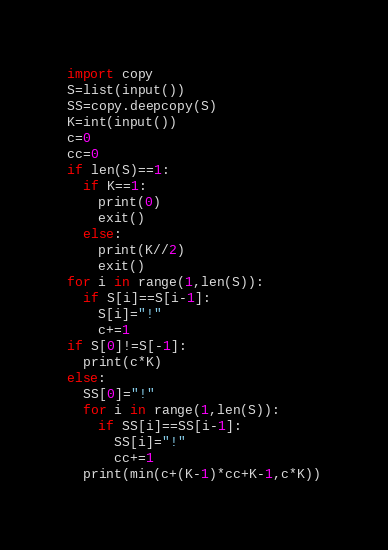<code> <loc_0><loc_0><loc_500><loc_500><_Python_>import copy
S=list(input())
SS=copy.deepcopy(S)
K=int(input())
c=0
cc=0
if len(S)==1:
  if K==1:
    print(0)
    exit()
  else:
    print(K//2)
    exit()
for i in range(1,len(S)):
  if S[i]==S[i-1]:
    S[i]="!"
    c+=1
if S[0]!=S[-1]:
  print(c*K)
else:
  SS[0]="!"
  for i in range(1,len(S)):
    if SS[i]==SS[i-1]:
      SS[i]="!"
      cc+=1
  print(min(c+(K-1)*cc+K-1,c*K))</code> 